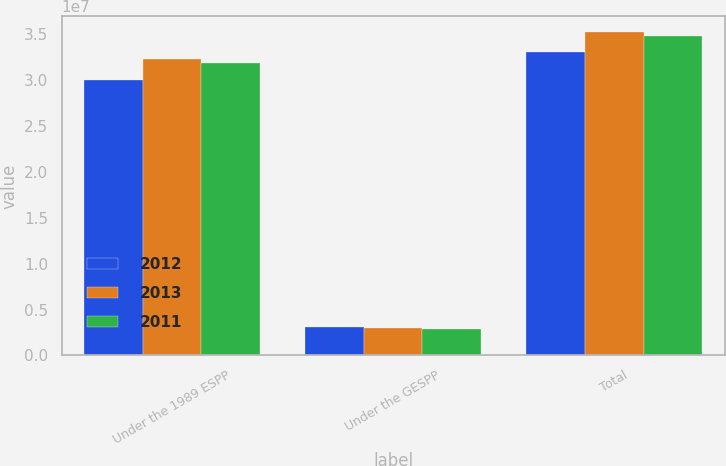<chart> <loc_0><loc_0><loc_500><loc_500><stacked_bar_chart><ecel><fcel>Under the 1989 ESPP<fcel>Under the GESPP<fcel>Total<nl><fcel>2012<fcel>3.00128e+07<fcel>3.06858e+06<fcel>3.30814e+07<nl><fcel>2013<fcel>3.22367e+07<fcel>2.94499e+06<fcel>3.51816e+07<nl><fcel>2011<fcel>3.18877e+07<fcel>2.8943e+06<fcel>3.4782e+07<nl></chart> 